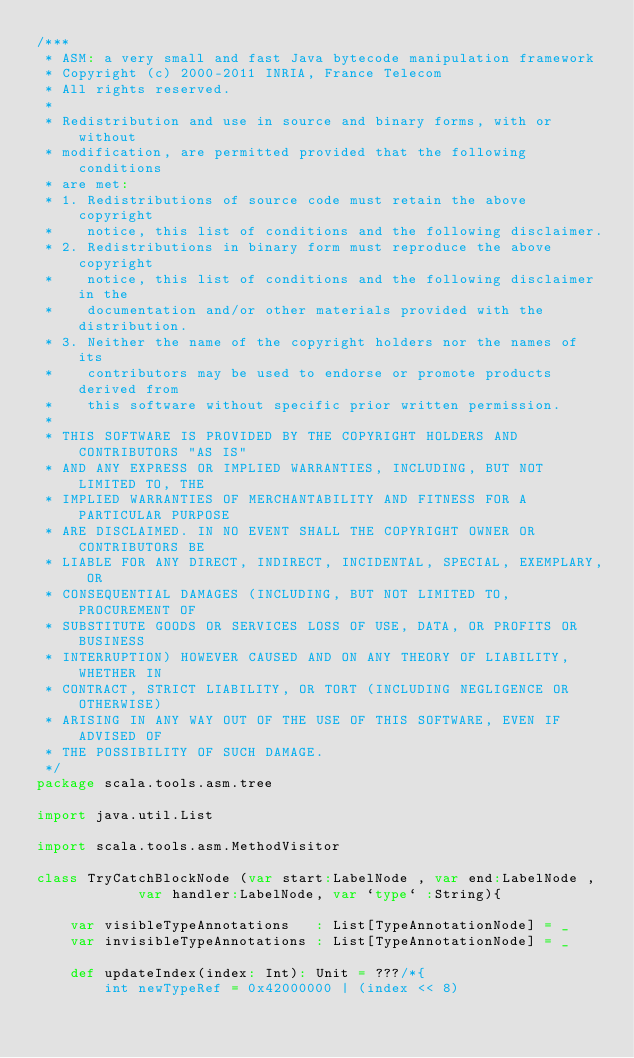<code> <loc_0><loc_0><loc_500><loc_500><_Scala_>/***
 * ASM: a very small and fast Java bytecode manipulation framework
 * Copyright (c) 2000-2011 INRIA, France Telecom
 * All rights reserved.
 *
 * Redistribution and use in source and binary forms, with or without
 * modification, are permitted provided that the following conditions
 * are met:
 * 1. Redistributions of source code must retain the above copyright
 *    notice, this list of conditions and the following disclaimer.
 * 2. Redistributions in binary form must reproduce the above copyright
 *    notice, this list of conditions and the following disclaimer in the
 *    documentation and/or other materials provided with the distribution.
 * 3. Neither the name of the copyright holders nor the names of its
 *    contributors may be used to endorse or promote products derived from
 *    this software without specific prior written permission.
 *
 * THIS SOFTWARE IS PROVIDED BY THE COPYRIGHT HOLDERS AND CONTRIBUTORS "AS IS"
 * AND ANY EXPRESS OR IMPLIED WARRANTIES, INCLUDING, BUT NOT LIMITED TO, THE
 * IMPLIED WARRANTIES OF MERCHANTABILITY AND FITNESS FOR A PARTICULAR PURPOSE
 * ARE DISCLAIMED. IN NO EVENT SHALL THE COPYRIGHT OWNER OR CONTRIBUTORS BE
 * LIABLE FOR ANY DIRECT, INDIRECT, INCIDENTAL, SPECIAL, EXEMPLARY, OR
 * CONSEQUENTIAL DAMAGES (INCLUDING, BUT NOT LIMITED TO, PROCUREMENT OF
 * SUBSTITUTE GOODS OR SERVICES LOSS OF USE, DATA, OR PROFITS OR BUSINESS
 * INTERRUPTION) HOWEVER CAUSED AND ON ANY THEORY OF LIABILITY, WHETHER IN
 * CONTRACT, STRICT LIABILITY, OR TORT (INCLUDING NEGLIGENCE OR OTHERWISE)
 * ARISING IN ANY WAY OUT OF THE USE OF THIS SOFTWARE, EVEN IF ADVISED OF
 * THE POSSIBILITY OF SUCH DAMAGE.
 */
package scala.tools.asm.tree

import java.util.List

import scala.tools.asm.MethodVisitor

class TryCatchBlockNode (var start:LabelNode , var end:LabelNode ,
            var handler:LabelNode, var `type` :String){

    var visibleTypeAnnotations   : List[TypeAnnotationNode] = _
    var invisibleTypeAnnotations : List[TypeAnnotationNode] = _

    def updateIndex(index: Int): Unit = ???/*{
        int newTypeRef = 0x42000000 | (index << 8)</code> 